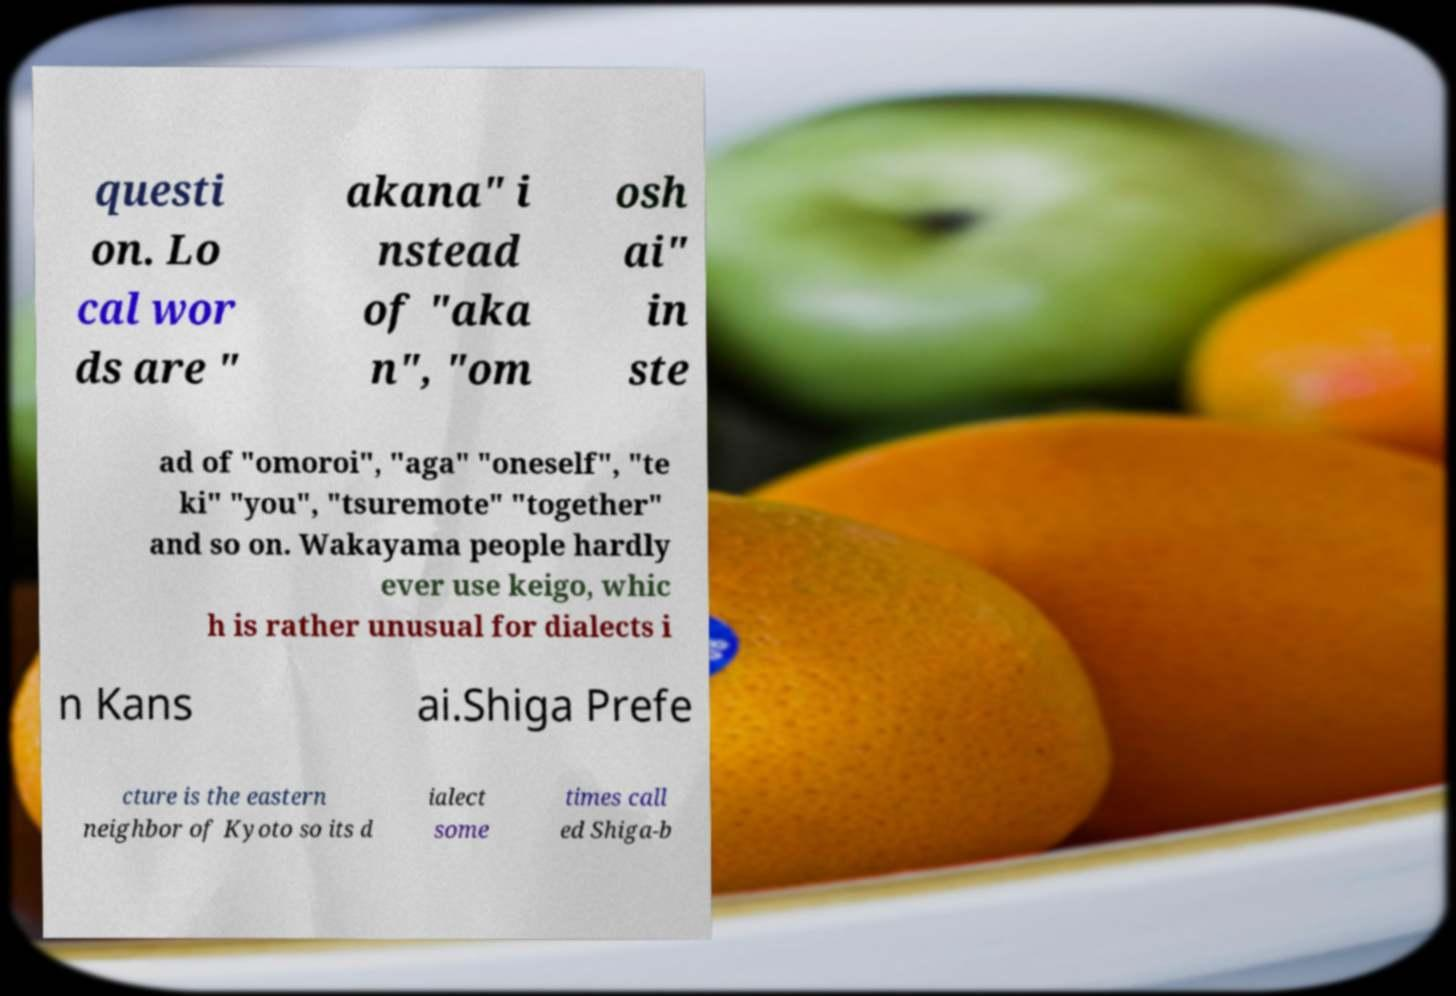Please read and relay the text visible in this image. What does it say? questi on. Lo cal wor ds are " akana" i nstead of "aka n", "om osh ai" in ste ad of "omoroi", "aga" "oneself", "te ki" "you", "tsuremote" "together" and so on. Wakayama people hardly ever use keigo, whic h is rather unusual for dialects i n Kans ai.Shiga Prefe cture is the eastern neighbor of Kyoto so its d ialect some times call ed Shiga-b 